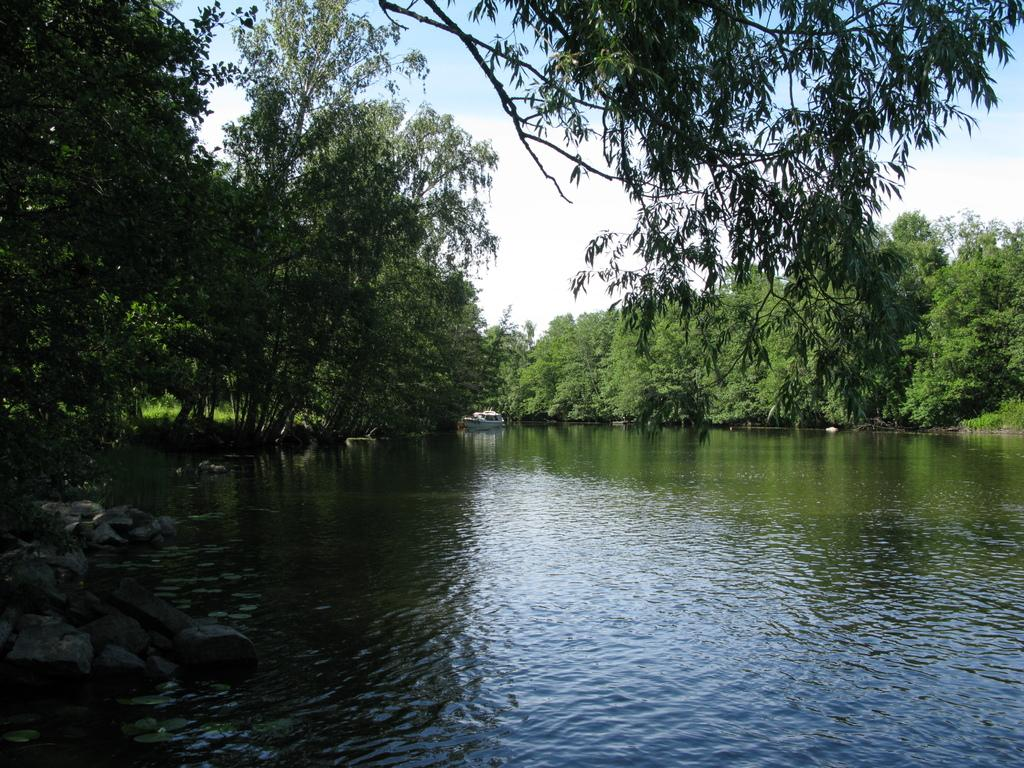What is present at the bottom of the image? There is water at the bottom of the image. What can be found in the center of the image? There are trees in the center of the image. What type of natural formation is on the left side of the image? There are rocks on the left side of the image. What is visible at the top of the image? The top side of the image has trees. Can you tell me how many basketballs are hidden among the rocks in the image? There are no basketballs present in the image; it features water, trees, and rocks. What type of wax is used to create the texture of the trees in the image? There is no wax used in the image; the trees are depicted using a different medium or technique. 